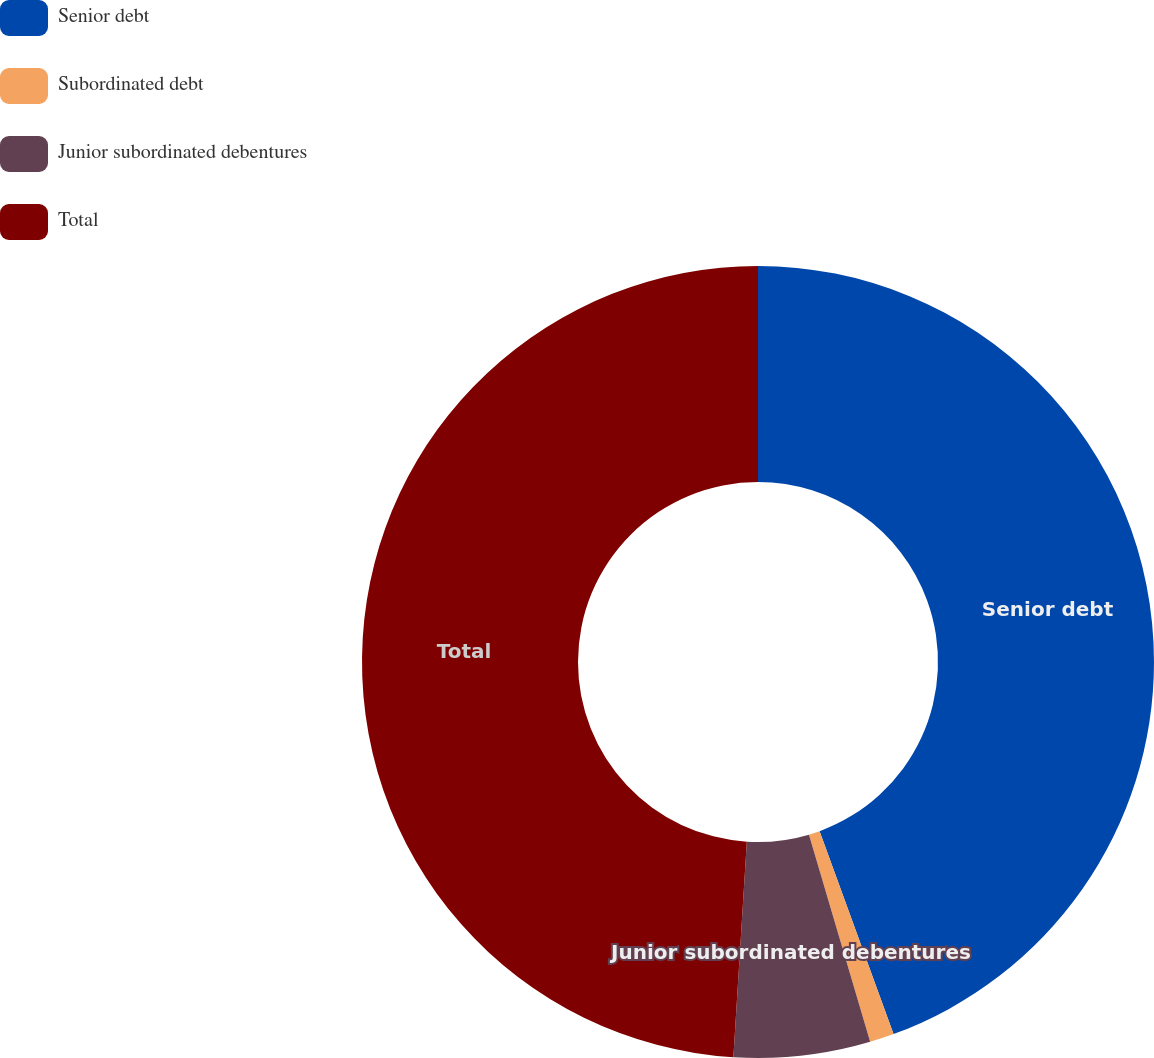<chart> <loc_0><loc_0><loc_500><loc_500><pie_chart><fcel>Senior debt<fcel>Subordinated debt<fcel>Junior subordinated debentures<fcel>Total<nl><fcel>44.44%<fcel>0.99%<fcel>5.56%<fcel>49.01%<nl></chart> 